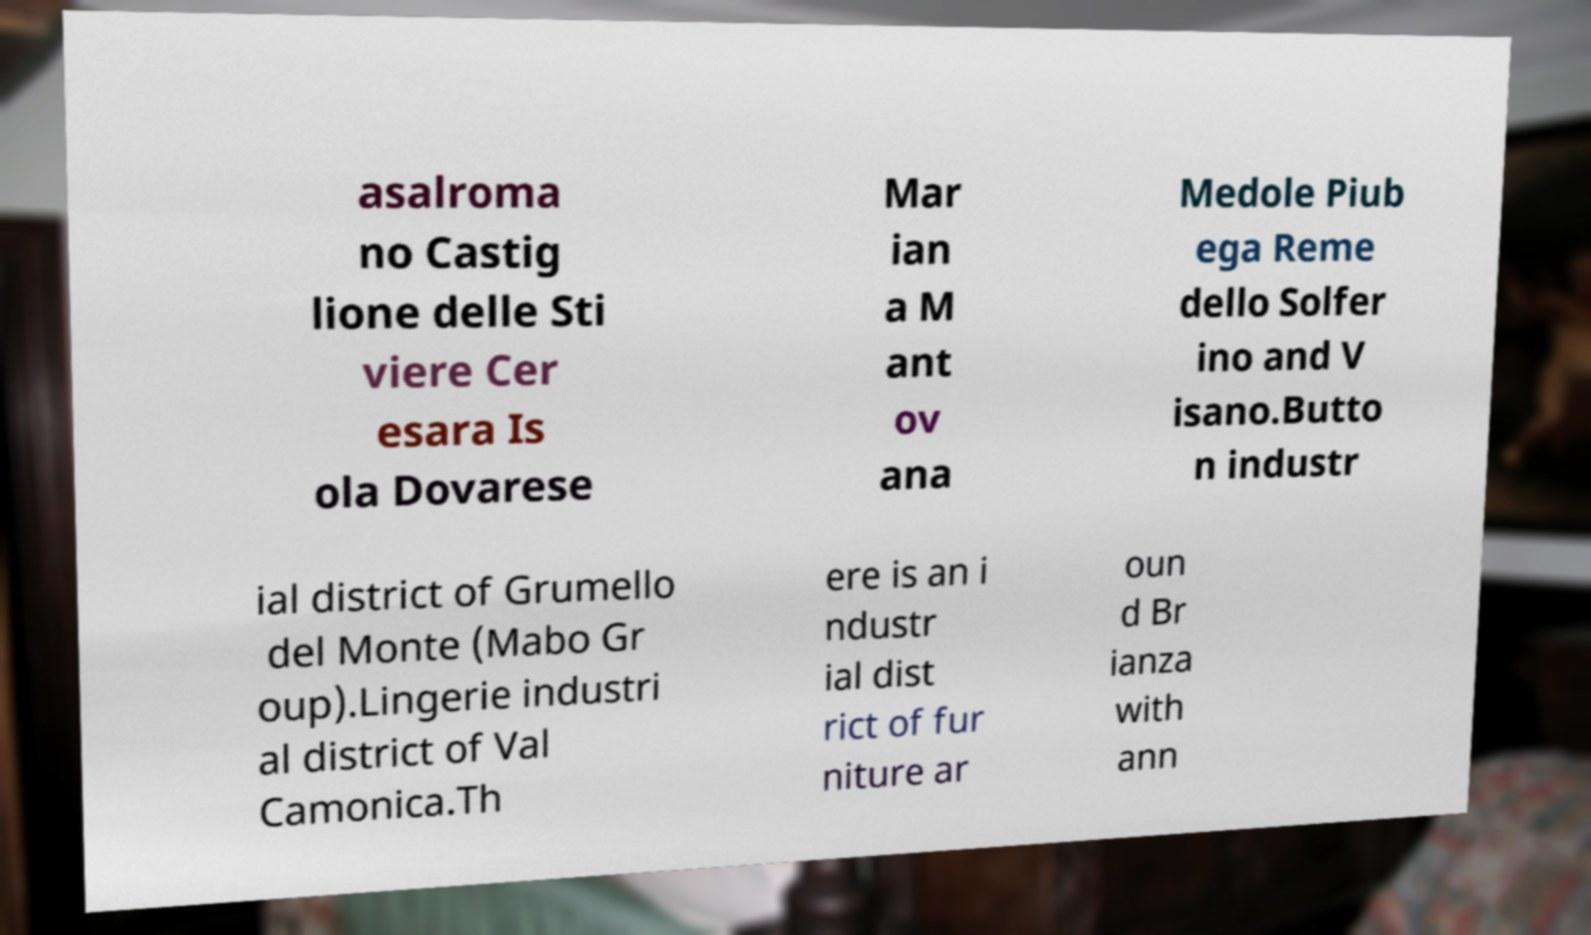Could you extract and type out the text from this image? asalroma no Castig lione delle Sti viere Cer esara Is ola Dovarese Mar ian a M ant ov ana Medole Piub ega Reme dello Solfer ino and V isano.Butto n industr ial district of Grumello del Monte (Mabo Gr oup).Lingerie industri al district of Val Camonica.Th ere is an i ndustr ial dist rict of fur niture ar oun d Br ianza with ann 